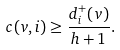Convert formula to latex. <formula><loc_0><loc_0><loc_500><loc_500>c ( v , i ) \geq \frac { d ^ { + } _ { i } ( v ) } { h + 1 } .</formula> 